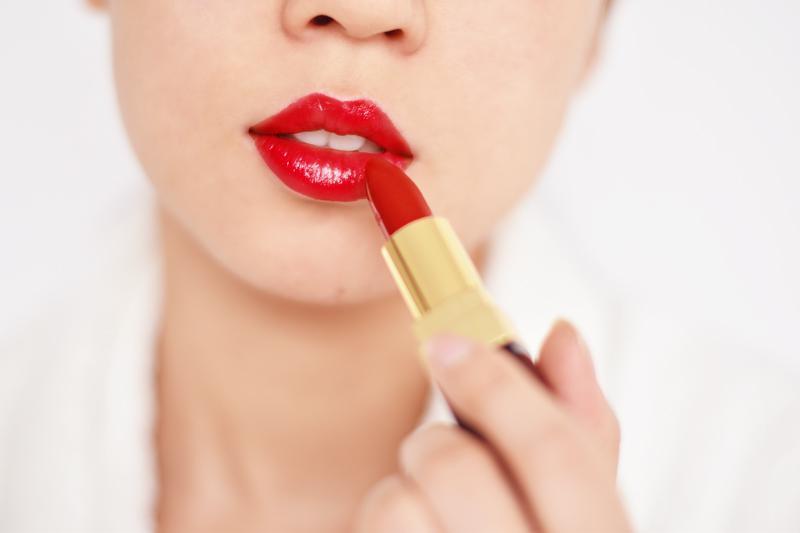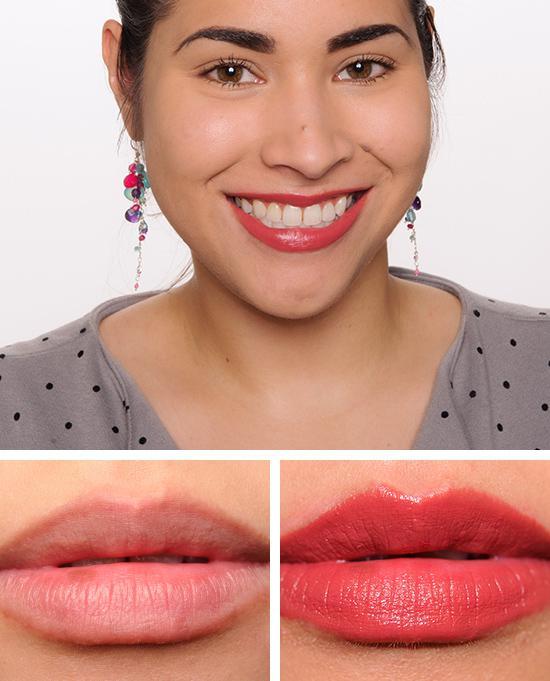The first image is the image on the left, the second image is the image on the right. For the images shown, is this caption "The right image contains a human wearing a large necklace." true? Answer yes or no. No. The first image is the image on the left, the second image is the image on the right. Given the left and right images, does the statement "An image shows untinted and tinted lips under the face of a smiling model." hold true? Answer yes or no. Yes. 